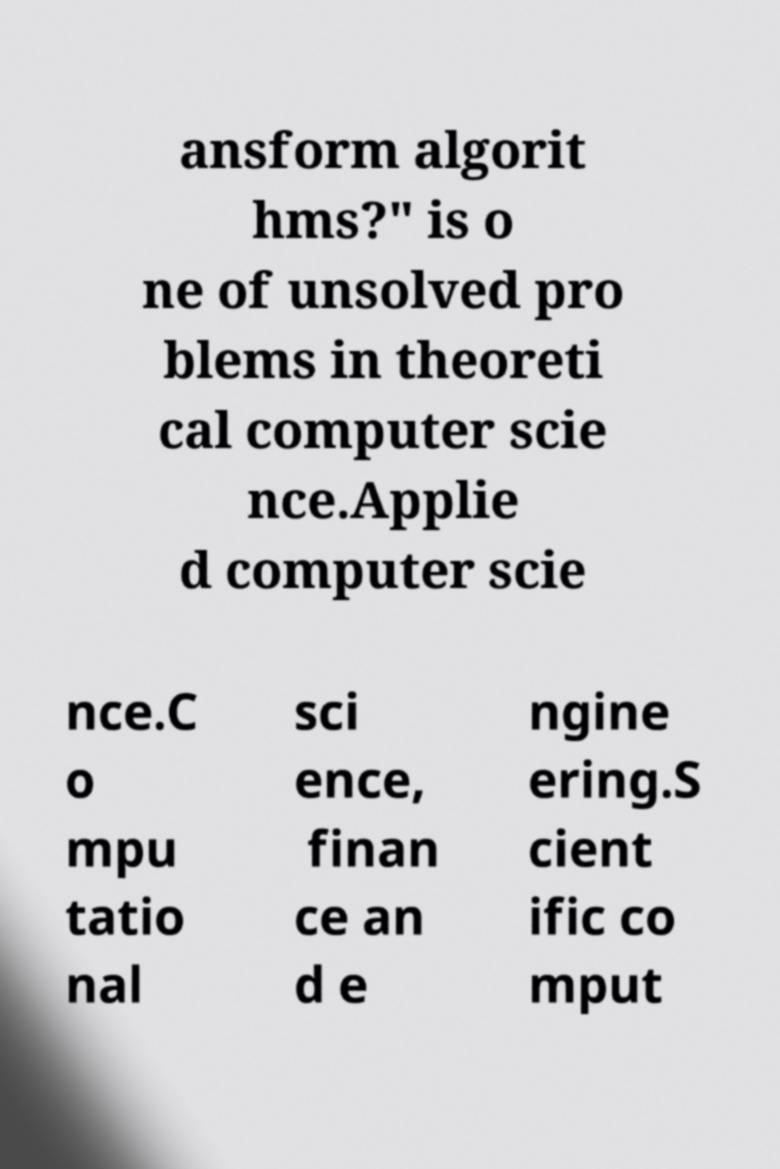For documentation purposes, I need the text within this image transcribed. Could you provide that? ansform algorit hms?" is o ne of unsolved pro blems in theoreti cal computer scie nce.Applie d computer scie nce.C o mpu tatio nal sci ence, finan ce an d e ngine ering.S cient ific co mput 